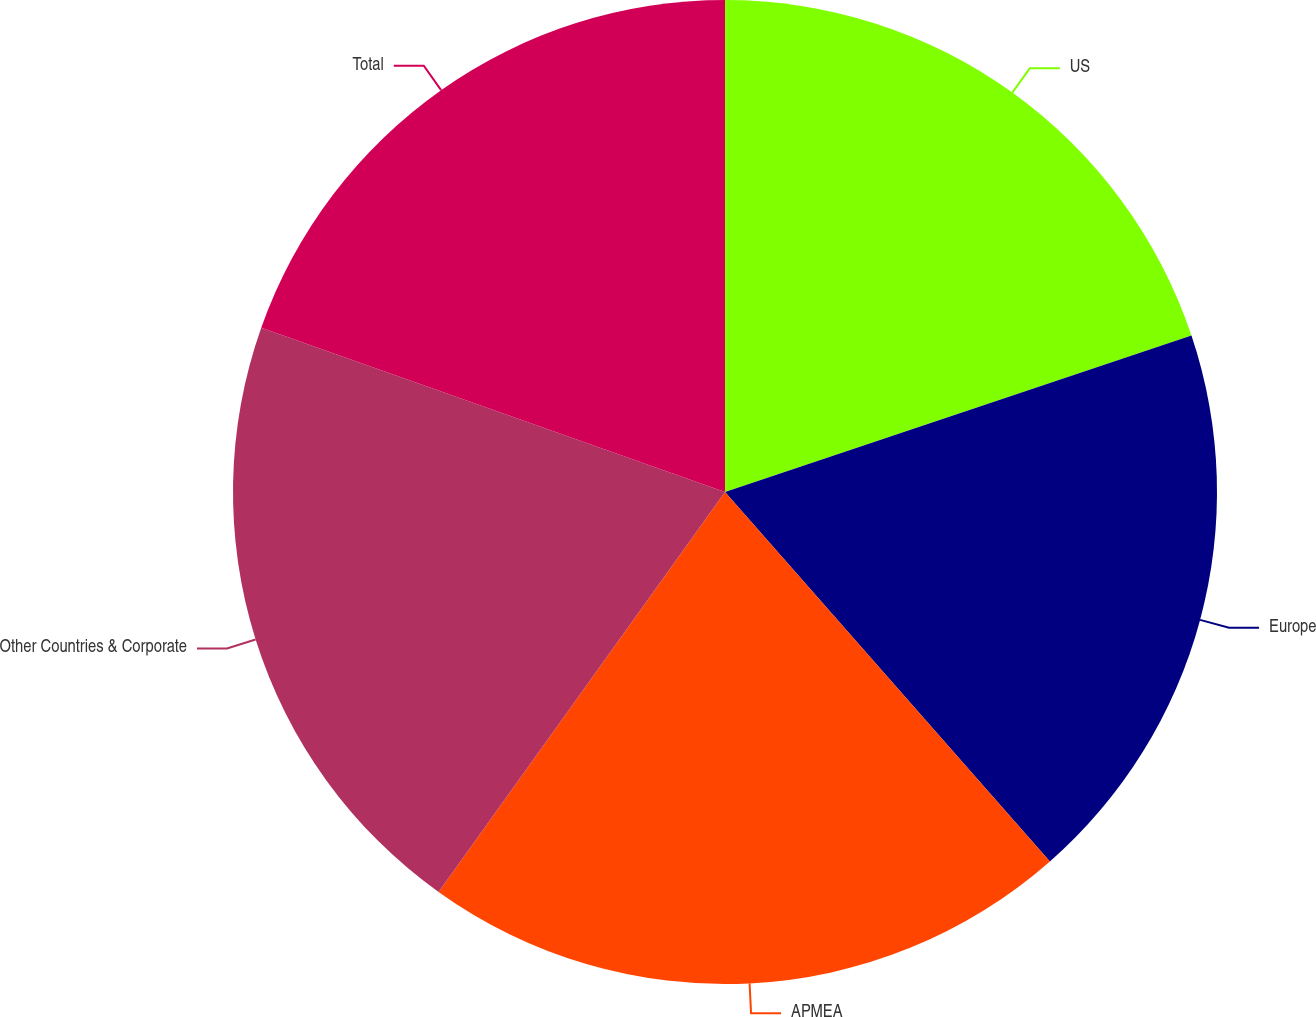<chart> <loc_0><loc_0><loc_500><loc_500><pie_chart><fcel>US<fcel>Europe<fcel>APMEA<fcel>Other Countries & Corporate<fcel>Total<nl><fcel>19.85%<fcel>18.67%<fcel>21.37%<fcel>20.53%<fcel>19.58%<nl></chart> 